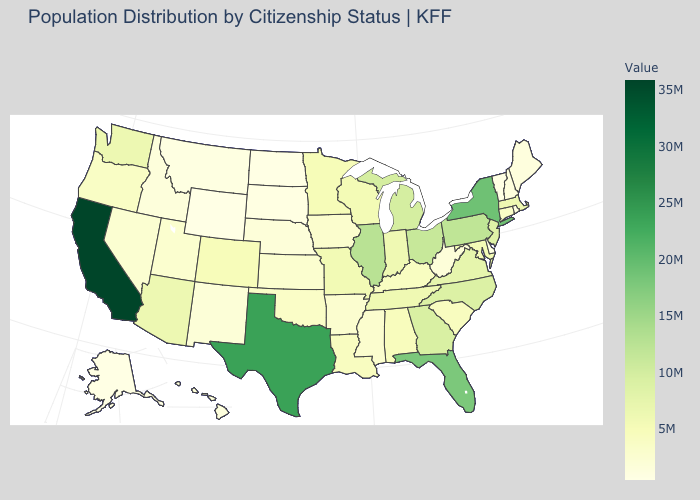Which states have the highest value in the USA?
Concise answer only. California. Which states have the highest value in the USA?
Quick response, please. California. Among the states that border Arizona , does New Mexico have the lowest value?
Quick response, please. Yes. 